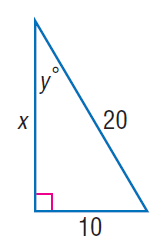Answer the mathemtical geometry problem and directly provide the correct option letter.
Question: Find y.
Choices: A: 30 B: 45 C: 60 D: 90 A 